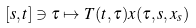<formula> <loc_0><loc_0><loc_500><loc_500>[ s , t ] \ni \tau \mapsto T ( t , \tau ) x ( \tau , s , x _ { s } )</formula> 